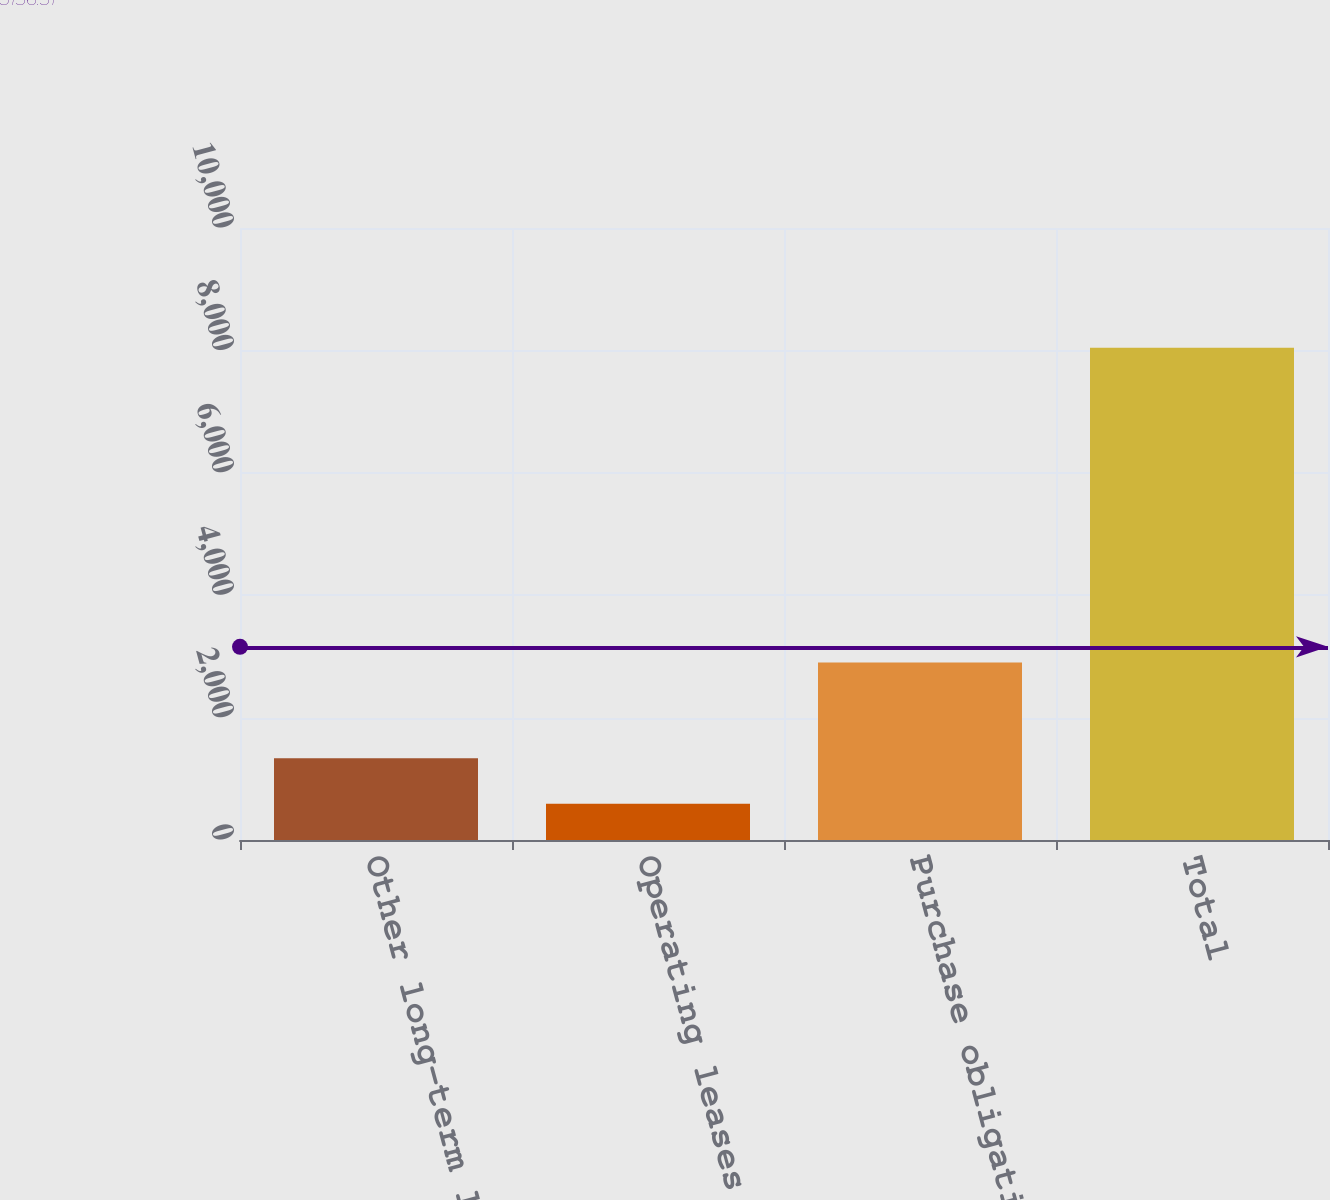Convert chart. <chart><loc_0><loc_0><loc_500><loc_500><bar_chart><fcel>Other long-term liabilities<fcel>Operating leases (Note 6)<fcel>Purchase obligations (c)<fcel>Total<nl><fcel>1337.2<fcel>592<fcel>2901<fcel>8044<nl></chart> 